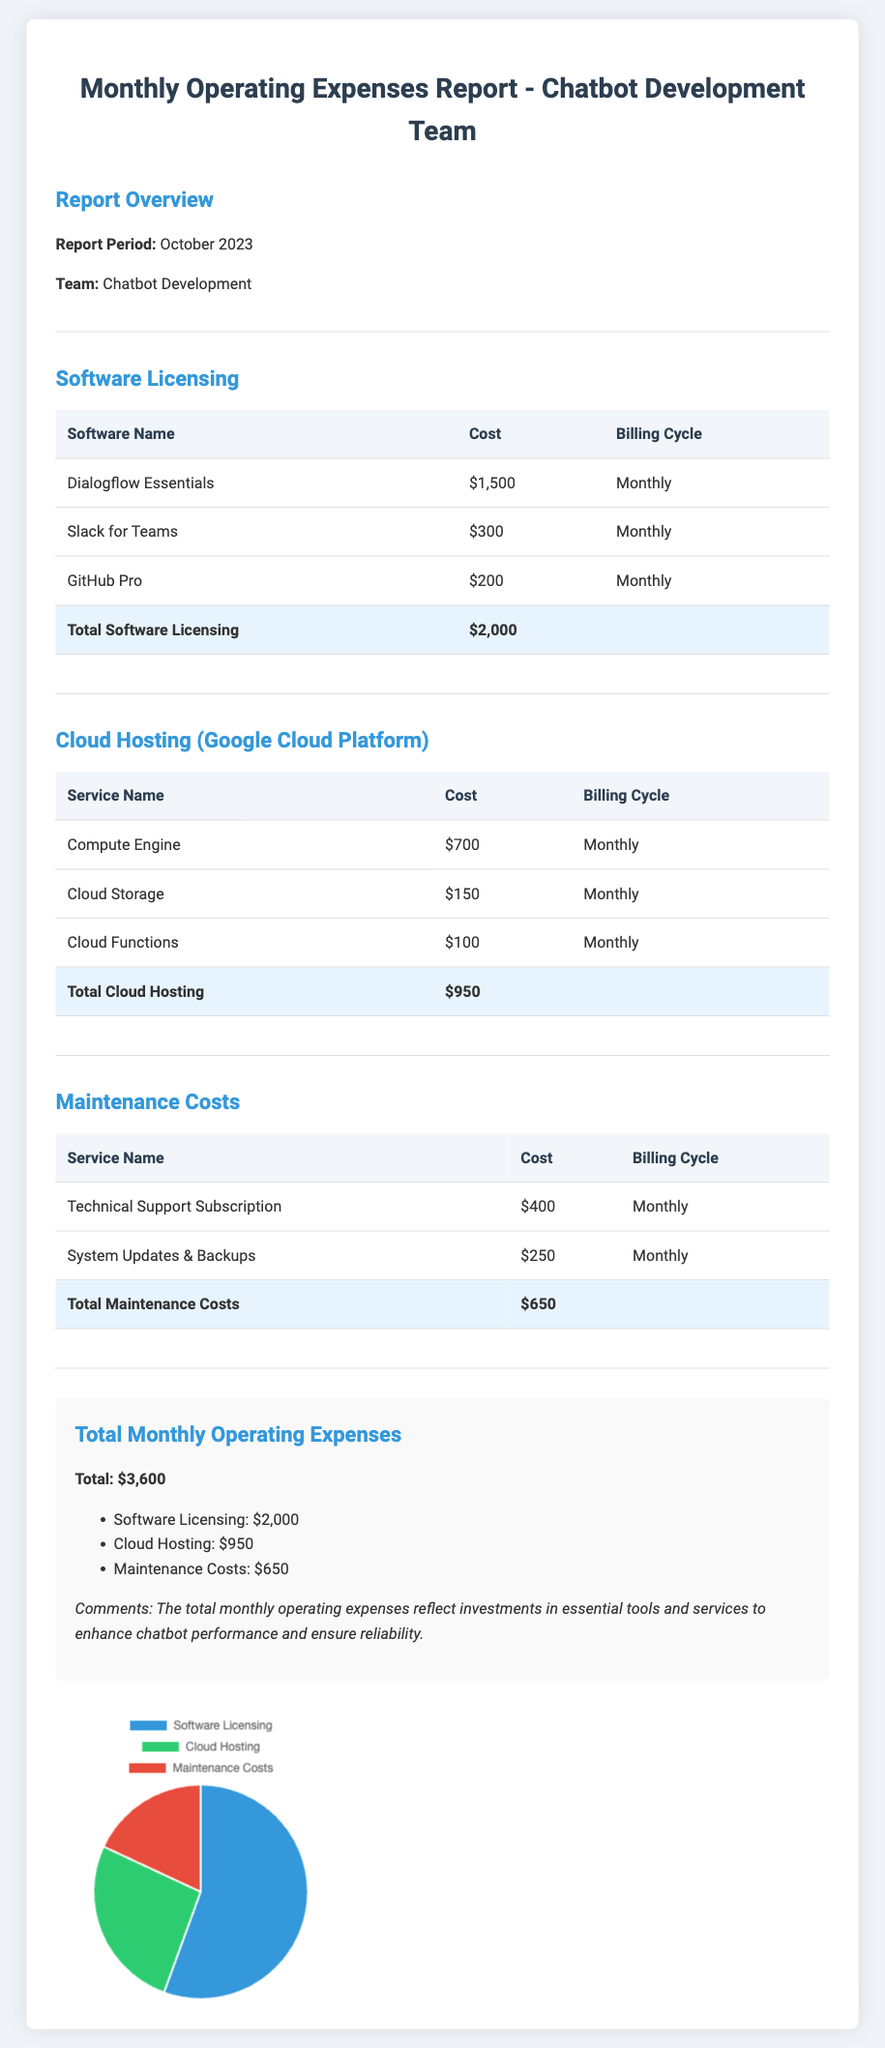what is the total software licensing cost? The total software licensing cost is listed at the bottom of the Software Licensing section of the document, which sums the individual costs.
Answer: $2,000 what is the billing cycle for GitHub Pro? The billing cycle for GitHub Pro is provided in the Software Licensing table, showing how frequently the cost is billed.
Answer: Monthly how much is spent on cloud storage? The cost for Cloud Storage is explicitly mentioned in the Cloud Hosting section of the document.
Answer: $150 what is the total monthly operating expenses? The total monthly operating expenses are summarized in the summary section, reflecting the combined costs from all sections of the report.
Answer: $3,600 which service has the highest cost? The service with the highest cost can be determined by comparing the costs listed in the Software Licensing section.
Answer: Dialogflow Essentials how much is allocated for maintenance costs? The maintenance costs are summed in the Maintenance Costs section of the document, providing a specific figure for total expenses in that area.
Answer: $650 what is the billing cycle for cloud functions? The billing cycle for Cloud Functions is indicated in the Cloud Hosting table, showing the frequency of costs for this service.
Answer: Monthly what percentage does software licensing contribute to total expenses? The percentage contribution of software licensing to total expenses can be calculated using the total expenses and the software licensing cost provided in the document.
Answer: 55.56% what is the name of the team related to this report? The team name is provided in the Report Overview section, indicating who this financial report pertains to.
Answer: Chatbot Development 